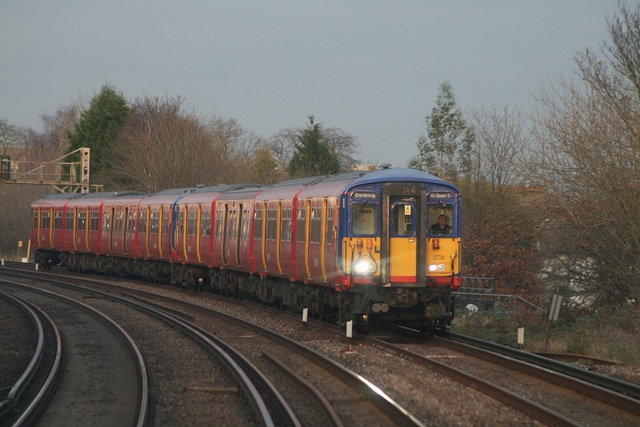Describe the objects in this image and their specific colors. I can see train in darkgray, black, gray, and maroon tones and people in darkgray, black, maroon, and gray tones in this image. 